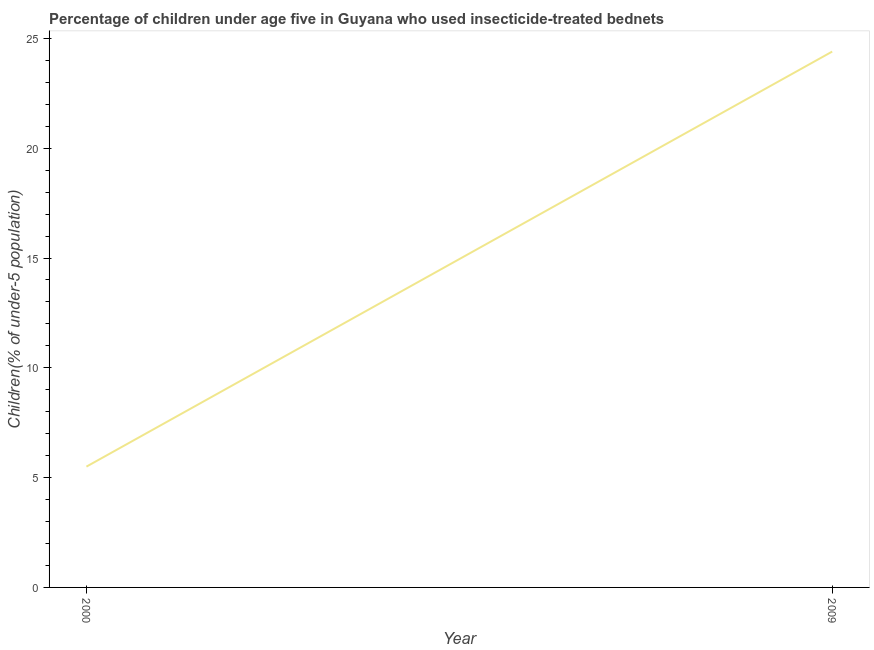What is the percentage of children who use of insecticide-treated bed nets in 2009?
Make the answer very short. 24.4. Across all years, what is the maximum percentage of children who use of insecticide-treated bed nets?
Make the answer very short. 24.4. Across all years, what is the minimum percentage of children who use of insecticide-treated bed nets?
Provide a succinct answer. 5.5. In which year was the percentage of children who use of insecticide-treated bed nets maximum?
Your response must be concise. 2009. In which year was the percentage of children who use of insecticide-treated bed nets minimum?
Your response must be concise. 2000. What is the sum of the percentage of children who use of insecticide-treated bed nets?
Make the answer very short. 29.9. What is the difference between the percentage of children who use of insecticide-treated bed nets in 2000 and 2009?
Keep it short and to the point. -18.9. What is the average percentage of children who use of insecticide-treated bed nets per year?
Your response must be concise. 14.95. What is the median percentage of children who use of insecticide-treated bed nets?
Provide a succinct answer. 14.95. Do a majority of the years between 2009 and 2000 (inclusive) have percentage of children who use of insecticide-treated bed nets greater than 6 %?
Give a very brief answer. No. What is the ratio of the percentage of children who use of insecticide-treated bed nets in 2000 to that in 2009?
Your answer should be compact. 0.23. Is the percentage of children who use of insecticide-treated bed nets in 2000 less than that in 2009?
Offer a very short reply. Yes. Does the percentage of children who use of insecticide-treated bed nets monotonically increase over the years?
Give a very brief answer. Yes. How many lines are there?
Offer a very short reply. 1. How many years are there in the graph?
Give a very brief answer. 2. Are the values on the major ticks of Y-axis written in scientific E-notation?
Keep it short and to the point. No. Does the graph contain any zero values?
Ensure brevity in your answer.  No. What is the title of the graph?
Provide a short and direct response. Percentage of children under age five in Guyana who used insecticide-treated bednets. What is the label or title of the Y-axis?
Keep it short and to the point. Children(% of under-5 population). What is the Children(% of under-5 population) of 2000?
Give a very brief answer. 5.5. What is the Children(% of under-5 population) in 2009?
Your answer should be very brief. 24.4. What is the difference between the Children(% of under-5 population) in 2000 and 2009?
Offer a very short reply. -18.9. What is the ratio of the Children(% of under-5 population) in 2000 to that in 2009?
Make the answer very short. 0.23. 